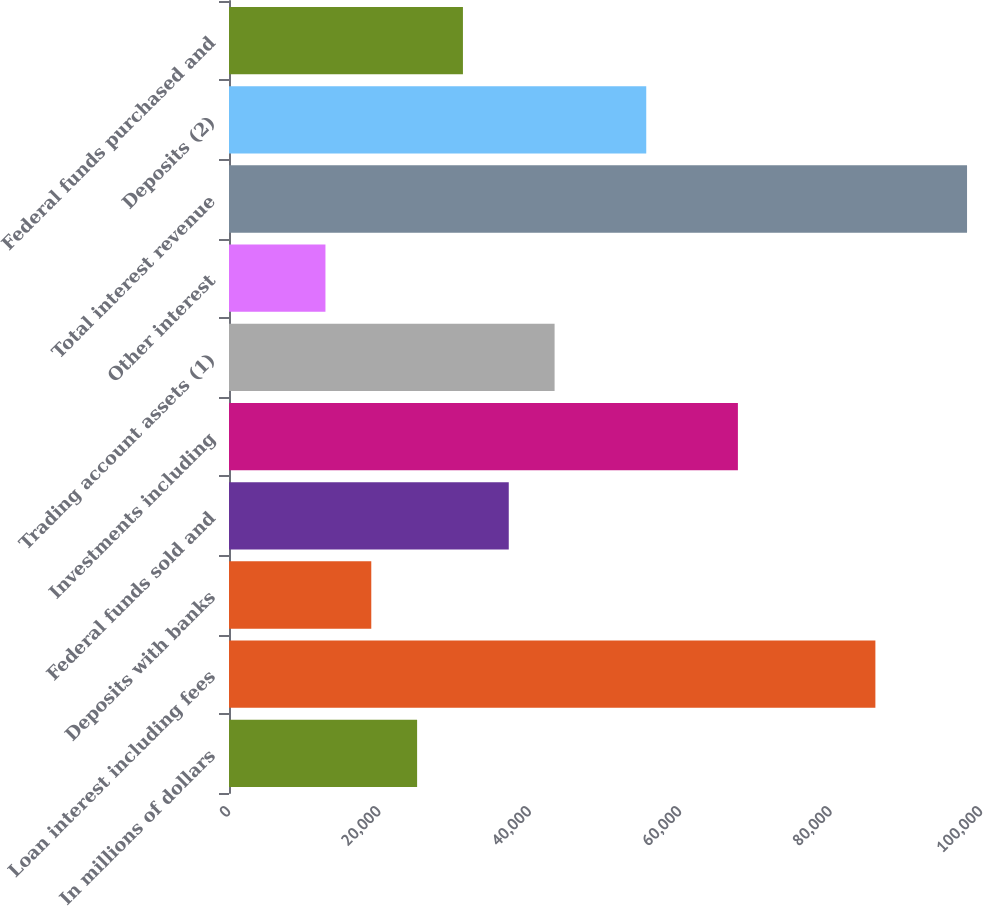<chart> <loc_0><loc_0><loc_500><loc_500><bar_chart><fcel>In millions of dollars<fcel>Loan interest including fees<fcel>Deposits with banks<fcel>Federal funds sold and<fcel>Investments including<fcel>Trading account assets (1)<fcel>Other interest<fcel>Total interest revenue<fcel>Deposits (2)<fcel>Federal funds purchased and<nl><fcel>25014.4<fcel>85955.4<fcel>18920.3<fcel>37202.6<fcel>67673.1<fcel>43296.7<fcel>12826.2<fcel>98143.6<fcel>55484.9<fcel>31108.5<nl></chart> 